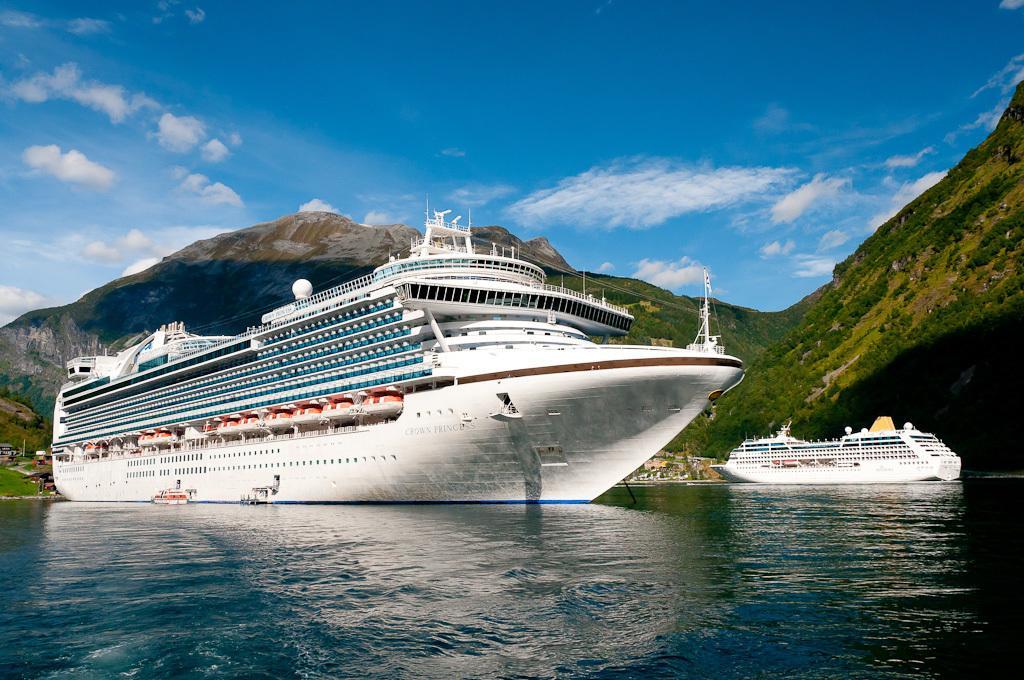In one or two sentences, can you explain what this image depicts? In this picture we can see two ships on water, mountains and in the background we can see the sky with clouds. 